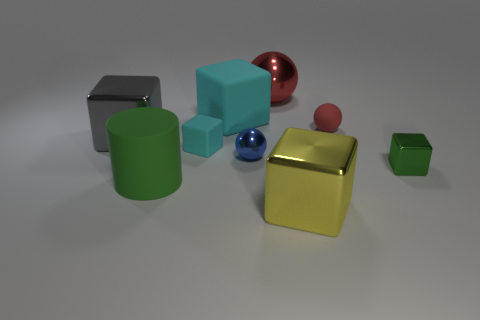Subtract all green cubes. How many cubes are left? 4 Subtract all small cyan matte cubes. How many cubes are left? 4 Subtract all cubes. How many objects are left? 4 Subtract all purple blocks. Subtract all cyan balls. How many blocks are left? 5 Add 9 cylinders. How many cylinders exist? 10 Subtract 0 gray cylinders. How many objects are left? 9 Subtract all small cyan rubber objects. Subtract all small blocks. How many objects are left? 6 Add 1 small metallic blocks. How many small metallic blocks are left? 2 